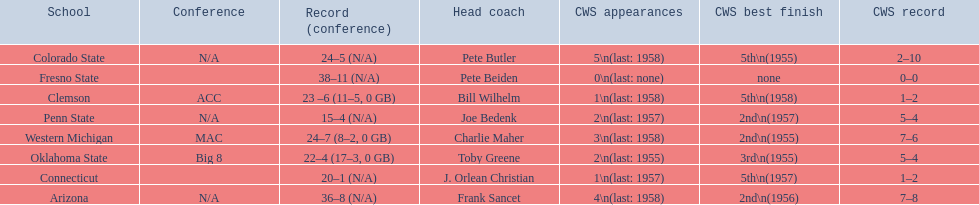What are the listed schools? Arizona, Clemson, Colorado State, Connecticut, Fresno State, Oklahoma State, Penn State, Western Michigan. Which are clemson and western michigan? Clemson, Western Michigan. What are their corresponding numbers of cws appearances? 1\n(last: 1958), 3\n(last: 1958). Which value is larger? 3\n(last: 1958). To which school does that value belong to? Western Michigan. 